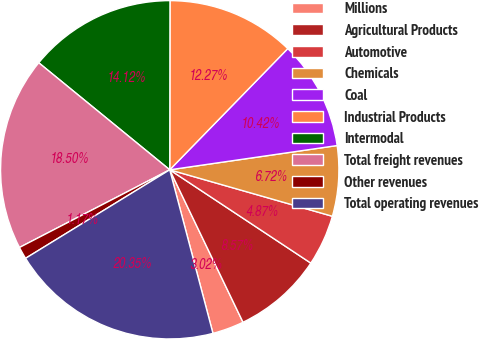<chart> <loc_0><loc_0><loc_500><loc_500><pie_chart><fcel>Millions<fcel>Agricultural Products<fcel>Automotive<fcel>Chemicals<fcel>Coal<fcel>Industrial Products<fcel>Intermodal<fcel>Total freight revenues<fcel>Other revenues<fcel>Total operating revenues<nl><fcel>3.02%<fcel>8.57%<fcel>4.87%<fcel>6.72%<fcel>10.42%<fcel>12.27%<fcel>14.12%<fcel>18.5%<fcel>1.17%<fcel>20.35%<nl></chart> 